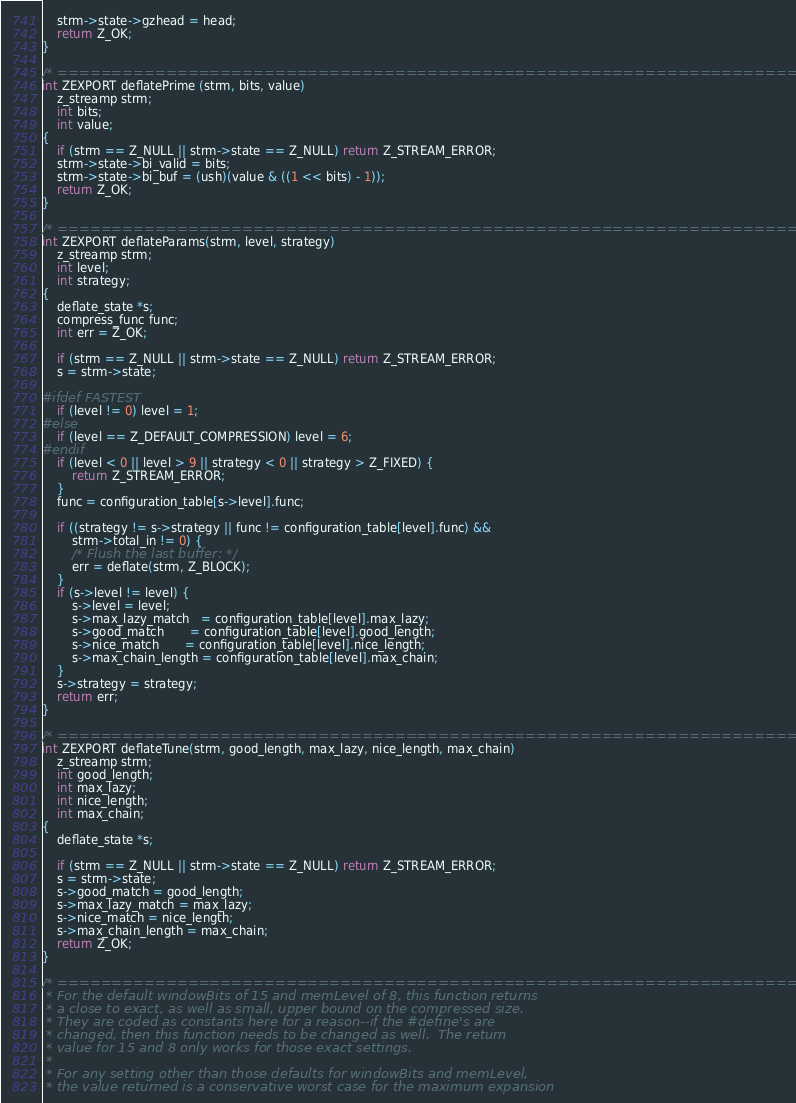Convert code to text. <code><loc_0><loc_0><loc_500><loc_500><_C_>    strm->state->gzhead = head;
    return Z_OK;
}

/* ========================================================================= */
int ZEXPORT deflatePrime (strm, bits, value)
    z_streamp strm;
    int bits;
    int value;
{
    if (strm == Z_NULL || strm->state == Z_NULL) return Z_STREAM_ERROR;
    strm->state->bi_valid = bits;
    strm->state->bi_buf = (ush)(value & ((1 << bits) - 1));
    return Z_OK;
}

/* ========================================================================= */
int ZEXPORT deflateParams(strm, level, strategy)
    z_streamp strm;
    int level;
    int strategy;
{
    deflate_state *s;
    compress_func func;
    int err = Z_OK;

    if (strm == Z_NULL || strm->state == Z_NULL) return Z_STREAM_ERROR;
    s = strm->state;

#ifdef FASTEST
    if (level != 0) level = 1;
#else
    if (level == Z_DEFAULT_COMPRESSION) level = 6;
#endif
    if (level < 0 || level > 9 || strategy < 0 || strategy > Z_FIXED) {
        return Z_STREAM_ERROR;
    }
    func = configuration_table[s->level].func;

    if ((strategy != s->strategy || func != configuration_table[level].func) &&
        strm->total_in != 0) {
        /* Flush the last buffer: */
        err = deflate(strm, Z_BLOCK);
    }
    if (s->level != level) {
        s->level = level;
        s->max_lazy_match   = configuration_table[level].max_lazy;
        s->good_match       = configuration_table[level].good_length;
        s->nice_match       = configuration_table[level].nice_length;
        s->max_chain_length = configuration_table[level].max_chain;
    }
    s->strategy = strategy;
    return err;
}

/* ========================================================================= */
int ZEXPORT deflateTune(strm, good_length, max_lazy, nice_length, max_chain)
    z_streamp strm;
    int good_length;
    int max_lazy;
    int nice_length;
    int max_chain;
{
    deflate_state *s;

    if (strm == Z_NULL || strm->state == Z_NULL) return Z_STREAM_ERROR;
    s = strm->state;
    s->good_match = good_length;
    s->max_lazy_match = max_lazy;
    s->nice_match = nice_length;
    s->max_chain_length = max_chain;
    return Z_OK;
}

/* =========================================================================
 * For the default windowBits of 15 and memLevel of 8, this function returns
 * a close to exact, as well as small, upper bound on the compressed size.
 * They are coded as constants here for a reason--if the #define's are
 * changed, then this function needs to be changed as well.  The return
 * value for 15 and 8 only works for those exact settings.
 *
 * For any setting other than those defaults for windowBits and memLevel,
 * the value returned is a conservative worst case for the maximum expansion</code> 